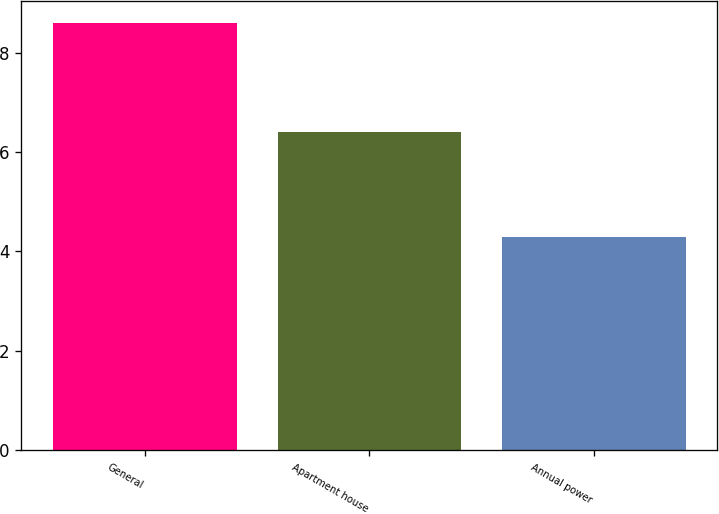Convert chart. <chart><loc_0><loc_0><loc_500><loc_500><bar_chart><fcel>General<fcel>Apartment house<fcel>Annual power<nl><fcel>8.6<fcel>6.4<fcel>4.3<nl></chart> 